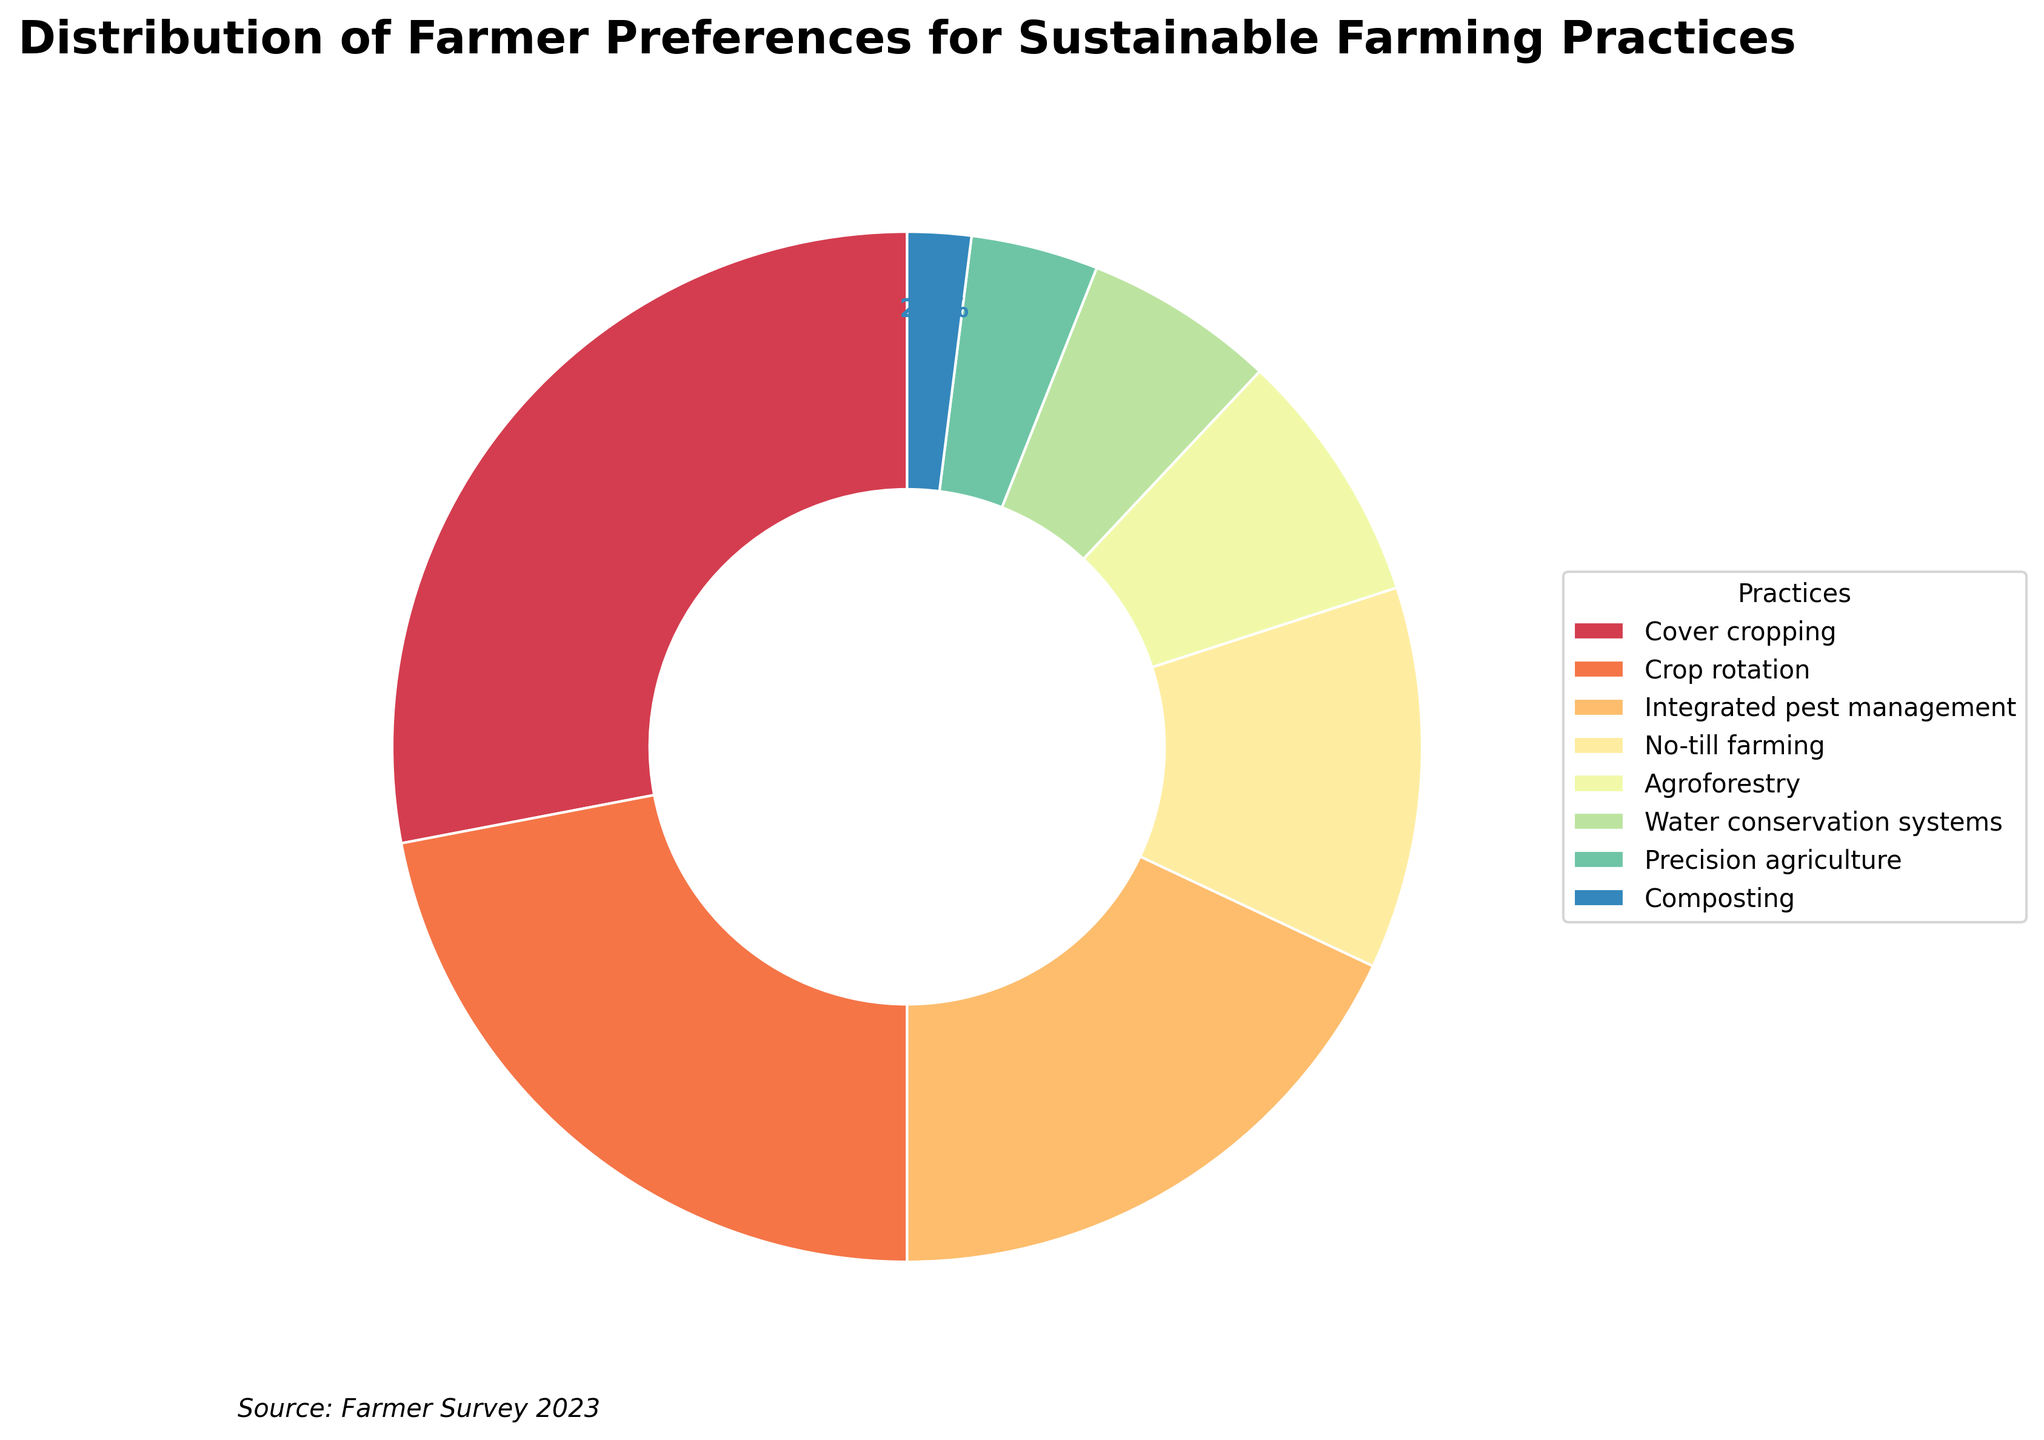What is the most preferred sustainable farming practice among farmers? By looking at the pie chart, we can see that the largest wedge represents Cover cropping, which has a percentage of 28%. Therefore, Cover cropping is the most preferred practice.
Answer: Cover cropping Which practice is less preferred, Agroforestry or Water conservation systems? Comparing the sizes of their wedges, Agroforestry is represented by 8% while Water conservation systems is represented by 6%. Therefore, Water conservation systems is less preferred.
Answer: Water conservation systems How many practices make up at least 50% of farmer preferences combined? Adding up the top practices from the largest wedge to smaller ones until reaching or surpassing 50%: Cover cropping (28%) + Crop rotation (22%) = 50%. So, two practices make up at least 50%.
Answer: Two What is the total percentage of farmers who prefer Integrated pest management and No-till farming combined? Adding the percentages for Integrated pest management (18%) and No-till farming (12%): 18% + 12% = 30%.
Answer: 30% Which practice has a smaller preference percentage: Crop rotation or Precision agriculture? Comparing the percentages, Crop rotation is 22% and Precision agriculture is 4%. Precision agriculture has a smaller preference percentage.
Answer: Precision agriculture How does the preference for Cover cropping compare to the total preference for Agroforestry, Water conservation systems, and Composting combined? Adding percentages of Agroforestry (8%), Water conservation systems (6%), and Composting (2%): 8% + 6% + 2% = 16%. Cover cropping is 28%, which is greater than 16%.
Answer: Cover cropping is greater What color is the wedge representing Crop rotation? The Crop rotation wedge is the second largest segment and can be observed in shades of the Spectral color map. By visual inspection, it appears to be in the orange region.
Answer: Orange Which sustainable farming practices combined account for the smallest cumulative percentage, and what is that percentage? The smallest percentages are Composting (2%) and Precision agriculture (4%). Adding them: 2% + 4% = 6%.
Answer: Composting and Precision agriculture, 6% Is there a practice that makes up less than 5% of the overall preferences? By reviewing the percentages, Precision agriculture (4%) and Composting (2%) are practices that make up less than 5%.
Answer: Yes What is the main color of the wedge with the lowest percentage? The wedge with the lowest percentage is Composting (2%), which appears in the darkest shade, typically representing the lower end of the Spectral colormap range, thus being dark violet.
Answer: Dark violet 